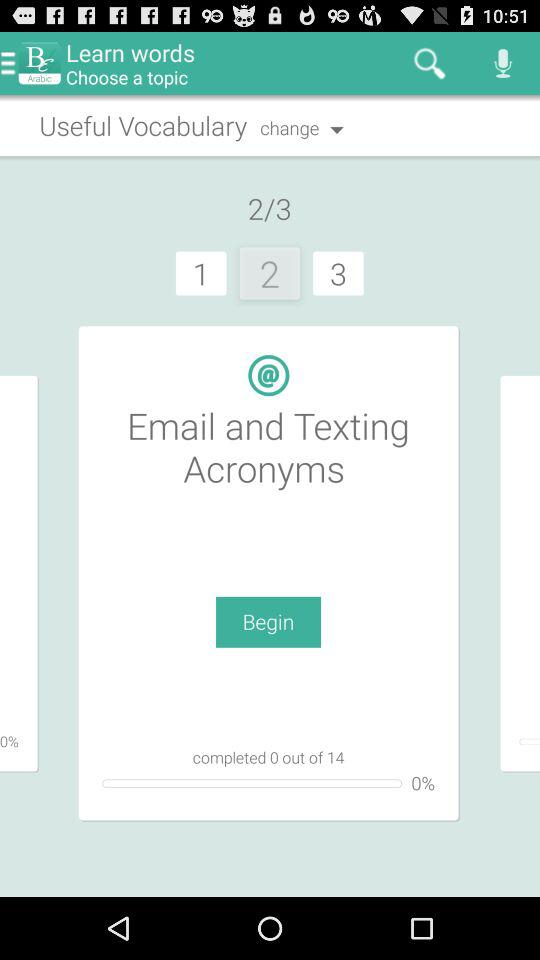What is the percentage of the lesson that has been completed?
Answer the question using a single word or phrase. 0% 